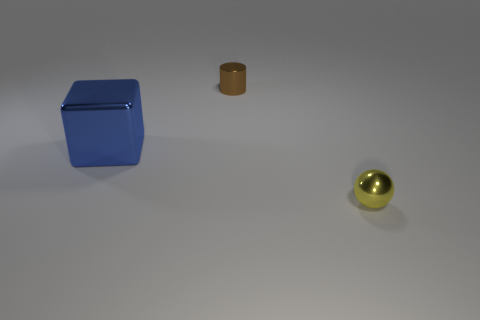Is the number of tiny brown shiny cylinders to the right of the big metal block less than the number of brown metallic objects that are to the left of the tiny cylinder?
Your answer should be very brief. No. What number of things are both to the right of the large metal thing and behind the yellow sphere?
Offer a very short reply. 1. Is the number of large things that are behind the blue metallic thing greater than the number of tiny balls that are right of the small brown object?
Offer a very short reply. No. The yellow metallic object has what size?
Make the answer very short. Small. Are there any other metal objects of the same shape as the yellow object?
Your answer should be compact. No. There is a brown thing; does it have the same shape as the tiny thing that is in front of the small brown metallic thing?
Keep it short and to the point. No. There is a metallic thing that is both on the right side of the large blue shiny object and to the left of the ball; what size is it?
Offer a very short reply. Small. What number of big metallic blocks are there?
Your response must be concise. 1. What material is the yellow ball that is the same size as the brown shiny cylinder?
Offer a very short reply. Metal. Is there a yellow metal object that has the same size as the yellow metal sphere?
Your answer should be compact. No. 